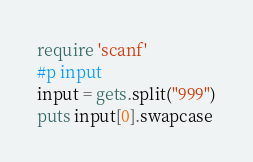<code> <loc_0><loc_0><loc_500><loc_500><_Ruby_>require 'scanf'
#p input
input = gets.split("999")
puts input[0].swapcase</code> 